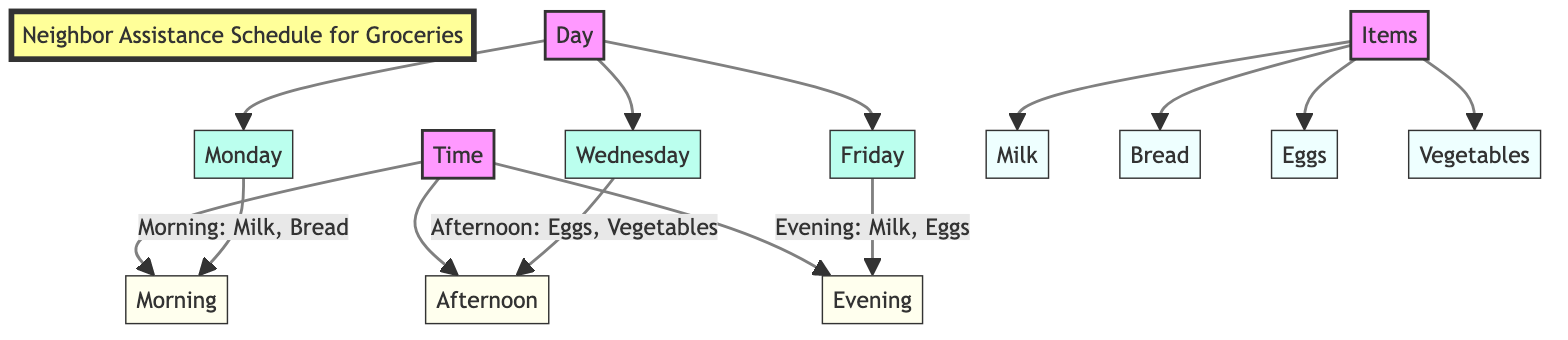What are the three days listed in the diagram? The diagram lists three specific days: Monday, Wednesday, and Friday. This information is directly shown under the "Day" category in the flowchart.
Answer: Monday, Wednesday, Friday Which time slot has items scheduled for Monday? Under the "Monday" node, the diagram specifies the time slot "Morning" with the items "Milk, Bread" associated with it.
Answer: Morning How many different items are indicated in the diagram? The diagram includes four distinct items: Milk, Bread, Eggs, and Vegetables, which are all represented under the "Items" category.
Answer: Four What items are scheduled for pickup on Wednesday? The diagram indicates that on Wednesday during the "Afternoon" slot, the items to be picked up are "Eggs, Vegetables." This information can be found in the connection from "Wednesday" to "Afternoon."
Answer: Eggs, Vegetables Which item is picked up in both the morning on Monday and the evening on Friday? By examining the connections, both the "Morning" slot for Monday and the "Evening" slot for Friday list "Milk" as an item, thus identifying it as the common item.
Answer: Milk How many time slots are represented in this diagram? Upon reviewing the "Time" category of the diagram, there are three distinct time slots: Morning, Afternoon, and Evening, leading to the conclusion that there are three time slots.
Answer: Three What is the last time slot for pickup during the week? The diagram reveals that the last time slot for pickup occurs on Friday and is designated as "Evening." This can be seen from the connections leading to "Friday."
Answer: Evening Which two items are assigned to the evening time slot? In the diagram, under the "Evening" time slot, the items listed for pickup on Friday are "Milk, Eggs," indicating these two items are scheduled together for that time.
Answer: Milk, Eggs 